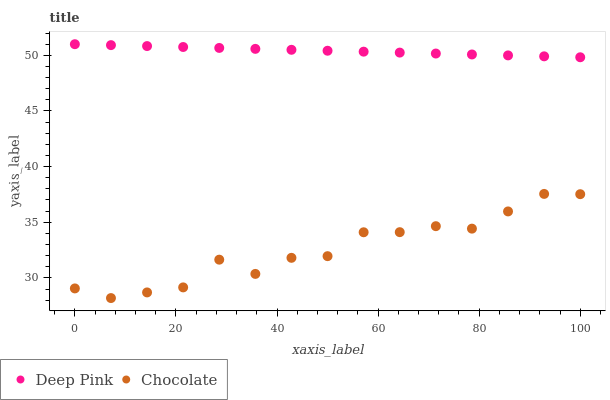Does Chocolate have the minimum area under the curve?
Answer yes or no. Yes. Does Deep Pink have the maximum area under the curve?
Answer yes or no. Yes. Does Chocolate have the maximum area under the curve?
Answer yes or no. No. Is Deep Pink the smoothest?
Answer yes or no. Yes. Is Chocolate the roughest?
Answer yes or no. Yes. Is Chocolate the smoothest?
Answer yes or no. No. Does Chocolate have the lowest value?
Answer yes or no. Yes. Does Deep Pink have the highest value?
Answer yes or no. Yes. Does Chocolate have the highest value?
Answer yes or no. No. Is Chocolate less than Deep Pink?
Answer yes or no. Yes. Is Deep Pink greater than Chocolate?
Answer yes or no. Yes. Does Chocolate intersect Deep Pink?
Answer yes or no. No. 